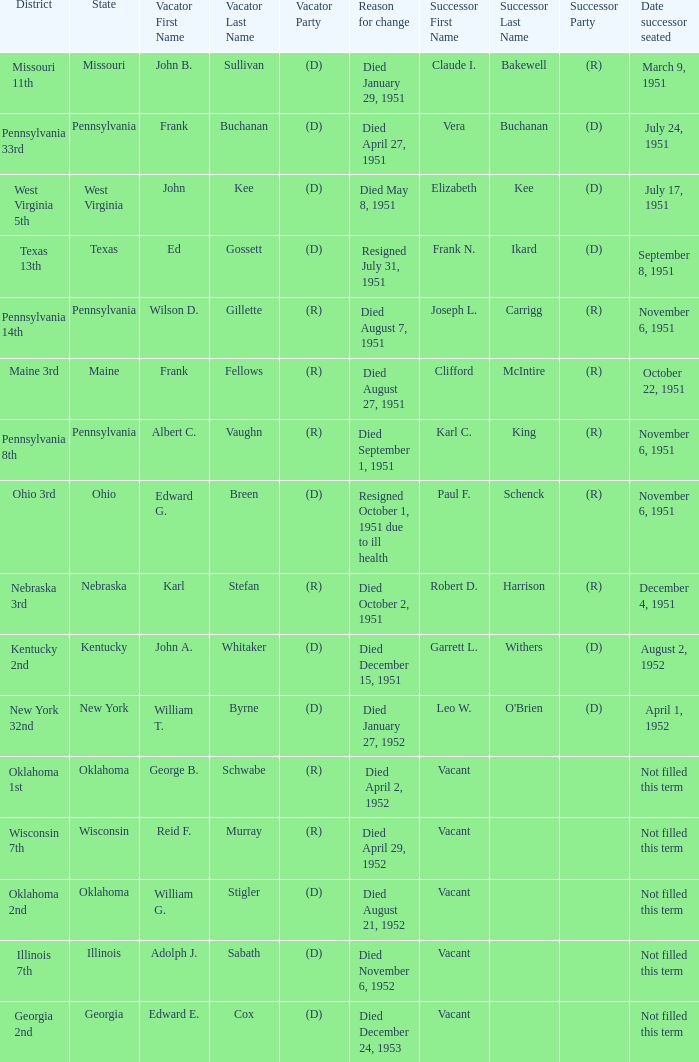Who was the successor for the Kentucky 2nd district? Garrett L. Withers (D). 